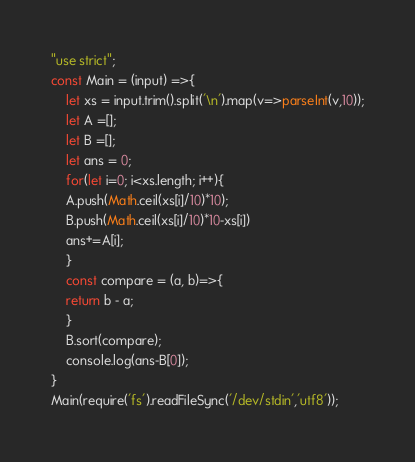Convert code to text. <code><loc_0><loc_0><loc_500><loc_500><_JavaScript_>"use strict";
const Main = (input) =>{
    let xs = input.trim().split('\n').map(v=>parseInt(v,10));
    let A =[];
    let B =[]; 
    let ans = 0;
    for(let i=0; i<xs.length; i++){
    A.push(Math.ceil(xs[i]/10)*10);
    B.push(Math.ceil(xs[i]/10)*10-xs[i])
    ans+=A[i];
    }
    const compare = (a, b)=>{ 
    return b - a;      
    }
    B.sort(compare); 
    console.log(ans-B[0]);
}
Main(require('fs').readFileSync('/dev/stdin','utf8'));</code> 